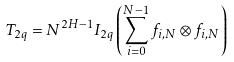Convert formula to latex. <formula><loc_0><loc_0><loc_500><loc_500>T _ { 2 q } = N ^ { 2 H - 1 } I _ { 2 q } \left ( \sum _ { i = 0 } ^ { N - 1 } f _ { i , N } \otimes f _ { i , N } \right )</formula> 